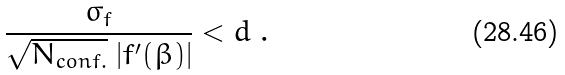Convert formula to latex. <formula><loc_0><loc_0><loc_500><loc_500>\frac { \sigma _ { f } } { \sqrt { N _ { c o n f . } } \ | f ^ { \prime } ( \beta ) | } < d \ .</formula> 